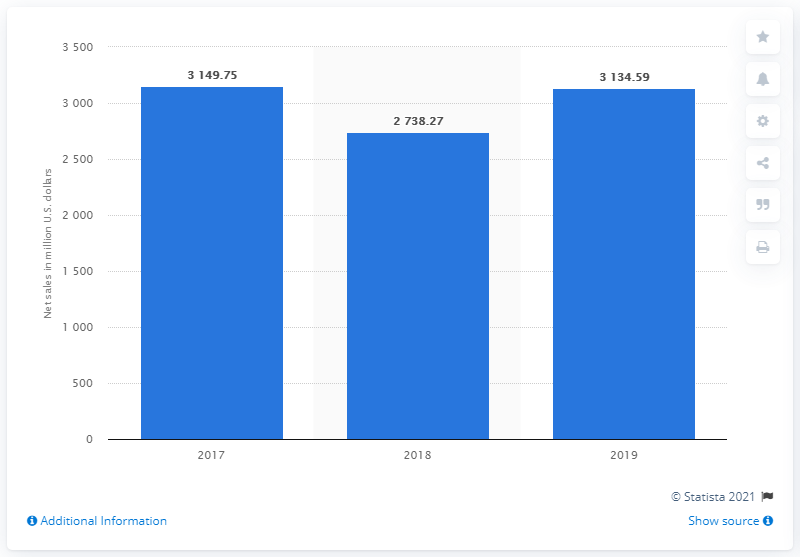Indicate a few pertinent items in this graphic. In fiscal year 2019, the net sales of H&M Group in the United States were 3134.59. 